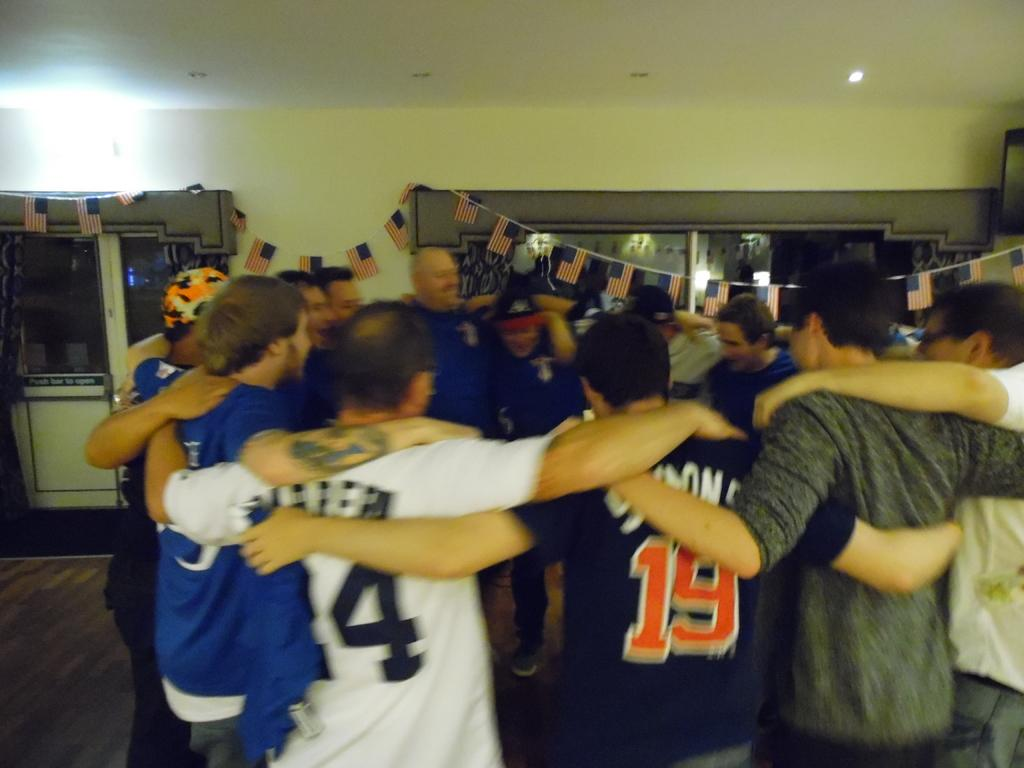<image>
Share a concise interpretation of the image provided. A bunch of people gather including one wearing number 19. 